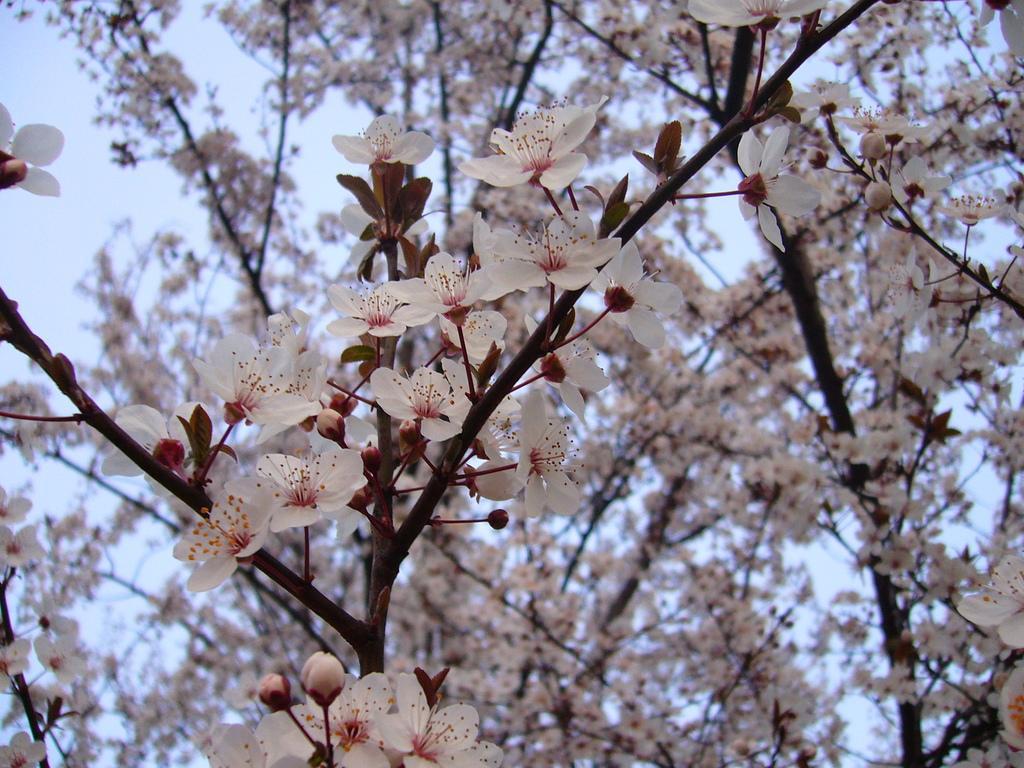In one or two sentences, can you explain what this image depicts? In this image I can see the flowers on the tree. In the background, I can see the sky. 